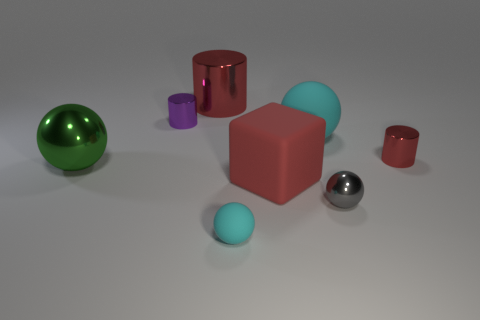Subtract 1 balls. How many balls are left? 3 Add 1 tiny gray metal objects. How many objects exist? 9 Subtract all cubes. How many objects are left? 7 Add 4 big red rubber things. How many big red rubber things exist? 5 Subtract 0 brown balls. How many objects are left? 8 Subtract all tiny purple shiny things. Subtract all tiny matte balls. How many objects are left? 6 Add 4 large cyan objects. How many large cyan objects are left? 5 